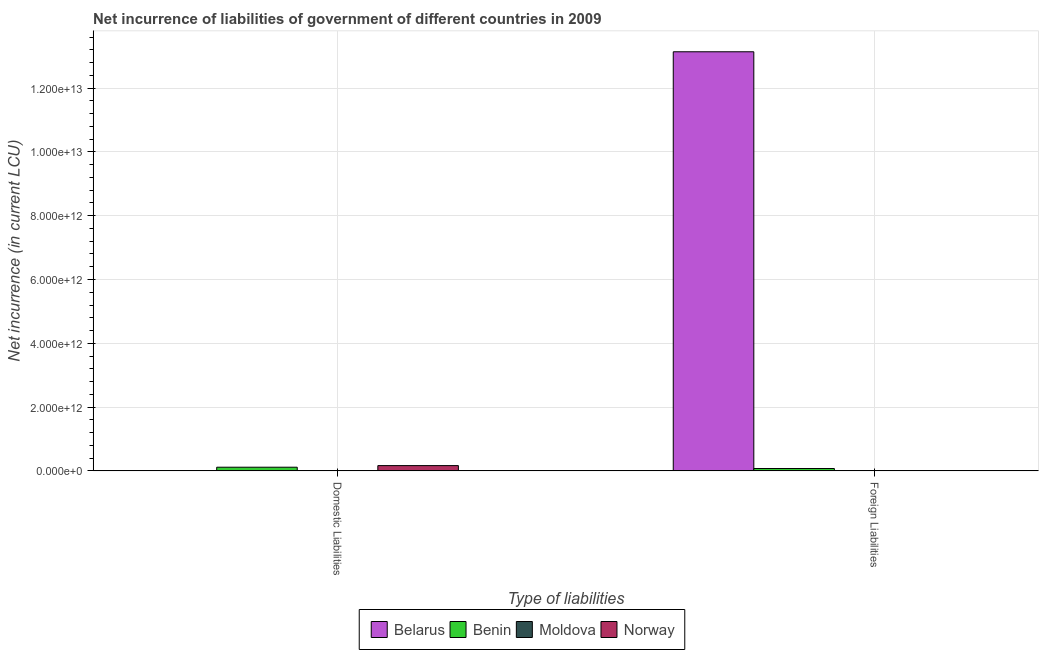How many groups of bars are there?
Make the answer very short. 2. Are the number of bars per tick equal to the number of legend labels?
Provide a short and direct response. No. Are the number of bars on each tick of the X-axis equal?
Your answer should be compact. Yes. How many bars are there on the 1st tick from the left?
Ensure brevity in your answer.  3. How many bars are there on the 1st tick from the right?
Your answer should be compact. 3. What is the label of the 1st group of bars from the left?
Offer a terse response. Domestic Liabilities. Across all countries, what is the maximum net incurrence of foreign liabilities?
Provide a short and direct response. 1.31e+13. Across all countries, what is the minimum net incurrence of domestic liabilities?
Your response must be concise. 0. In which country was the net incurrence of foreign liabilities maximum?
Keep it short and to the point. Belarus. What is the total net incurrence of domestic liabilities in the graph?
Your answer should be compact. 2.83e+11. What is the difference between the net incurrence of foreign liabilities in Belarus and that in Moldova?
Your response must be concise. 1.31e+13. What is the difference between the net incurrence of domestic liabilities in Benin and the net incurrence of foreign liabilities in Norway?
Make the answer very short. 1.15e+11. What is the average net incurrence of domestic liabilities per country?
Make the answer very short. 7.07e+1. What is the difference between the net incurrence of foreign liabilities and net incurrence of domestic liabilities in Benin?
Your response must be concise. -4.07e+1. What is the ratio of the net incurrence of domestic liabilities in Benin to that in Norway?
Your response must be concise. 0.69. In how many countries, is the net incurrence of foreign liabilities greater than the average net incurrence of foreign liabilities taken over all countries?
Offer a terse response. 1. How many bars are there?
Provide a succinct answer. 6. Are all the bars in the graph horizontal?
Keep it short and to the point. No. What is the difference between two consecutive major ticks on the Y-axis?
Your answer should be compact. 2.00e+12. Are the values on the major ticks of Y-axis written in scientific E-notation?
Your response must be concise. Yes. Does the graph contain any zero values?
Make the answer very short. Yes. Does the graph contain grids?
Your response must be concise. Yes. How many legend labels are there?
Ensure brevity in your answer.  4. What is the title of the graph?
Your answer should be very brief. Net incurrence of liabilities of government of different countries in 2009. What is the label or title of the X-axis?
Your response must be concise. Type of liabilities. What is the label or title of the Y-axis?
Your response must be concise. Net incurrence (in current LCU). What is the Net incurrence (in current LCU) of Benin in Domestic Liabilities?
Ensure brevity in your answer.  1.15e+11. What is the Net incurrence (in current LCU) in Moldova in Domestic Liabilities?
Offer a very short reply. 1.61e+09. What is the Net incurrence (in current LCU) in Norway in Domestic Liabilities?
Offer a very short reply. 1.66e+11. What is the Net incurrence (in current LCU) of Belarus in Foreign Liabilities?
Give a very brief answer. 1.31e+13. What is the Net incurrence (in current LCU) in Benin in Foreign Liabilities?
Your answer should be very brief. 7.46e+1. What is the Net incurrence (in current LCU) of Moldova in Foreign Liabilities?
Your response must be concise. 1.97e+09. What is the Net incurrence (in current LCU) of Norway in Foreign Liabilities?
Offer a very short reply. 0. Across all Type of liabilities, what is the maximum Net incurrence (in current LCU) of Belarus?
Ensure brevity in your answer.  1.31e+13. Across all Type of liabilities, what is the maximum Net incurrence (in current LCU) of Benin?
Your response must be concise. 1.15e+11. Across all Type of liabilities, what is the maximum Net incurrence (in current LCU) in Moldova?
Ensure brevity in your answer.  1.97e+09. Across all Type of liabilities, what is the maximum Net incurrence (in current LCU) in Norway?
Keep it short and to the point. 1.66e+11. Across all Type of liabilities, what is the minimum Net incurrence (in current LCU) in Belarus?
Keep it short and to the point. 0. Across all Type of liabilities, what is the minimum Net incurrence (in current LCU) in Benin?
Provide a short and direct response. 7.46e+1. Across all Type of liabilities, what is the minimum Net incurrence (in current LCU) in Moldova?
Give a very brief answer. 1.61e+09. What is the total Net incurrence (in current LCU) in Belarus in the graph?
Make the answer very short. 1.31e+13. What is the total Net incurrence (in current LCU) of Benin in the graph?
Give a very brief answer. 1.90e+11. What is the total Net incurrence (in current LCU) of Moldova in the graph?
Offer a terse response. 3.58e+09. What is the total Net incurrence (in current LCU) in Norway in the graph?
Your answer should be very brief. 1.66e+11. What is the difference between the Net incurrence (in current LCU) of Benin in Domestic Liabilities and that in Foreign Liabilities?
Offer a terse response. 4.07e+1. What is the difference between the Net incurrence (in current LCU) of Moldova in Domestic Liabilities and that in Foreign Liabilities?
Offer a terse response. -3.59e+08. What is the difference between the Net incurrence (in current LCU) of Benin in Domestic Liabilities and the Net incurrence (in current LCU) of Moldova in Foreign Liabilities?
Your response must be concise. 1.13e+11. What is the average Net incurrence (in current LCU) in Belarus per Type of liabilities?
Ensure brevity in your answer.  6.57e+12. What is the average Net incurrence (in current LCU) in Benin per Type of liabilities?
Keep it short and to the point. 9.50e+1. What is the average Net incurrence (in current LCU) of Moldova per Type of liabilities?
Provide a succinct answer. 1.79e+09. What is the average Net incurrence (in current LCU) in Norway per Type of liabilities?
Provide a succinct answer. 8.30e+1. What is the difference between the Net incurrence (in current LCU) in Benin and Net incurrence (in current LCU) in Moldova in Domestic Liabilities?
Keep it short and to the point. 1.14e+11. What is the difference between the Net incurrence (in current LCU) of Benin and Net incurrence (in current LCU) of Norway in Domestic Liabilities?
Keep it short and to the point. -5.07e+1. What is the difference between the Net incurrence (in current LCU) in Moldova and Net incurrence (in current LCU) in Norway in Domestic Liabilities?
Make the answer very short. -1.64e+11. What is the difference between the Net incurrence (in current LCU) of Belarus and Net incurrence (in current LCU) of Benin in Foreign Liabilities?
Provide a succinct answer. 1.31e+13. What is the difference between the Net incurrence (in current LCU) in Belarus and Net incurrence (in current LCU) in Moldova in Foreign Liabilities?
Provide a succinct answer. 1.31e+13. What is the difference between the Net incurrence (in current LCU) in Benin and Net incurrence (in current LCU) in Moldova in Foreign Liabilities?
Make the answer very short. 7.27e+1. What is the ratio of the Net incurrence (in current LCU) in Benin in Domestic Liabilities to that in Foreign Liabilities?
Offer a terse response. 1.55. What is the ratio of the Net incurrence (in current LCU) of Moldova in Domestic Liabilities to that in Foreign Liabilities?
Your answer should be compact. 0.82. What is the difference between the highest and the second highest Net incurrence (in current LCU) in Benin?
Keep it short and to the point. 4.07e+1. What is the difference between the highest and the second highest Net incurrence (in current LCU) in Moldova?
Provide a short and direct response. 3.59e+08. What is the difference between the highest and the lowest Net incurrence (in current LCU) of Belarus?
Give a very brief answer. 1.31e+13. What is the difference between the highest and the lowest Net incurrence (in current LCU) of Benin?
Ensure brevity in your answer.  4.07e+1. What is the difference between the highest and the lowest Net incurrence (in current LCU) in Moldova?
Your answer should be very brief. 3.59e+08. What is the difference between the highest and the lowest Net incurrence (in current LCU) of Norway?
Give a very brief answer. 1.66e+11. 